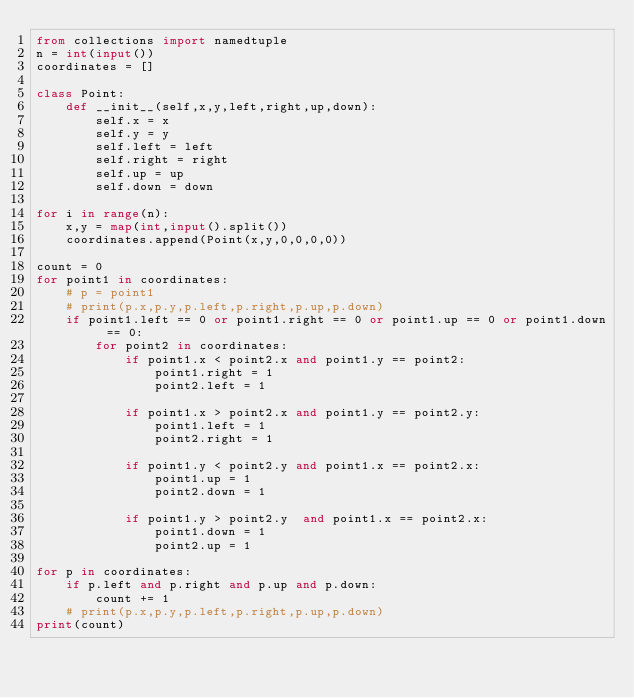Convert code to text. <code><loc_0><loc_0><loc_500><loc_500><_Python_>from collections import namedtuple
n = int(input())
coordinates = []

class Point:
    def __init__(self,x,y,left,right,up,down):
        self.x = x
        self.y = y 
        self.left = left
        self.right = right 
        self.up = up 
        self.down = down
        
for i in range(n):
    x,y = map(int,input().split())
    coordinates.append(Point(x,y,0,0,0,0))

count = 0
for point1 in coordinates:
    # p = point1
    # print(p.x,p.y,p.left,p.right,p.up,p.down)
    if point1.left == 0 or point1.right == 0 or point1.up == 0 or point1.down == 0:
        for point2 in coordinates:
            if point1.x < point2.x and point1.y == point2:
                point1.right = 1
                point2.left = 1
            
            if point1.x > point2.x and point1.y == point2.y:
                point1.left = 1
                point2.right = 1
            
            if point1.y < point2.y and point1.x == point2.x:
                point1.up = 1
                point2.down = 1
            
            if point1.y > point2.y  and point1.x == point2.x:
                point1.down = 1
                point2.up = 1
            
for p in coordinates:
    if p.left and p.right and p.up and p.down:
        count += 1
    # print(p.x,p.y,p.left,p.right,p.up,p.down)
print(count)





    </code> 